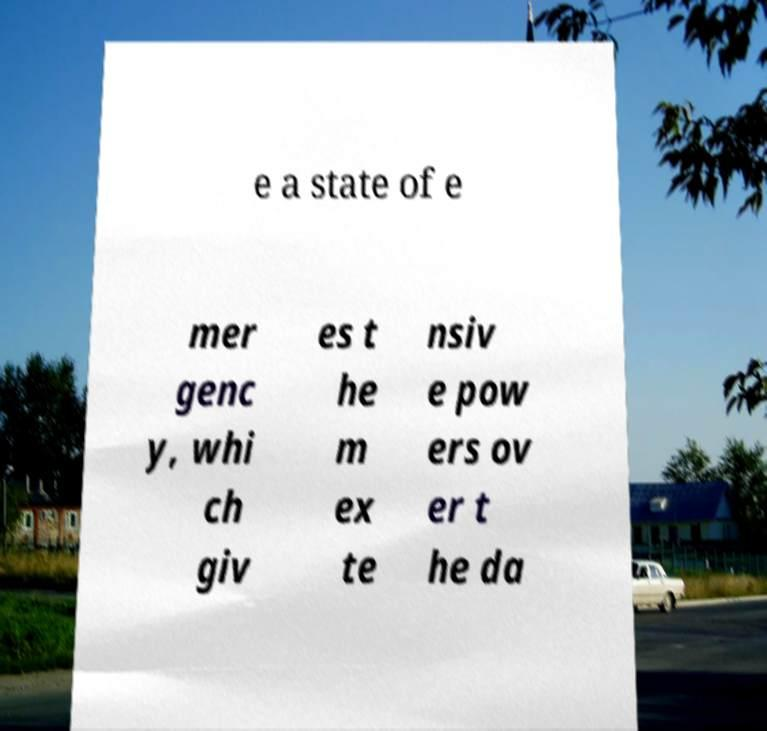Could you extract and type out the text from this image? e a state of e mer genc y, whi ch giv es t he m ex te nsiv e pow ers ov er t he da 